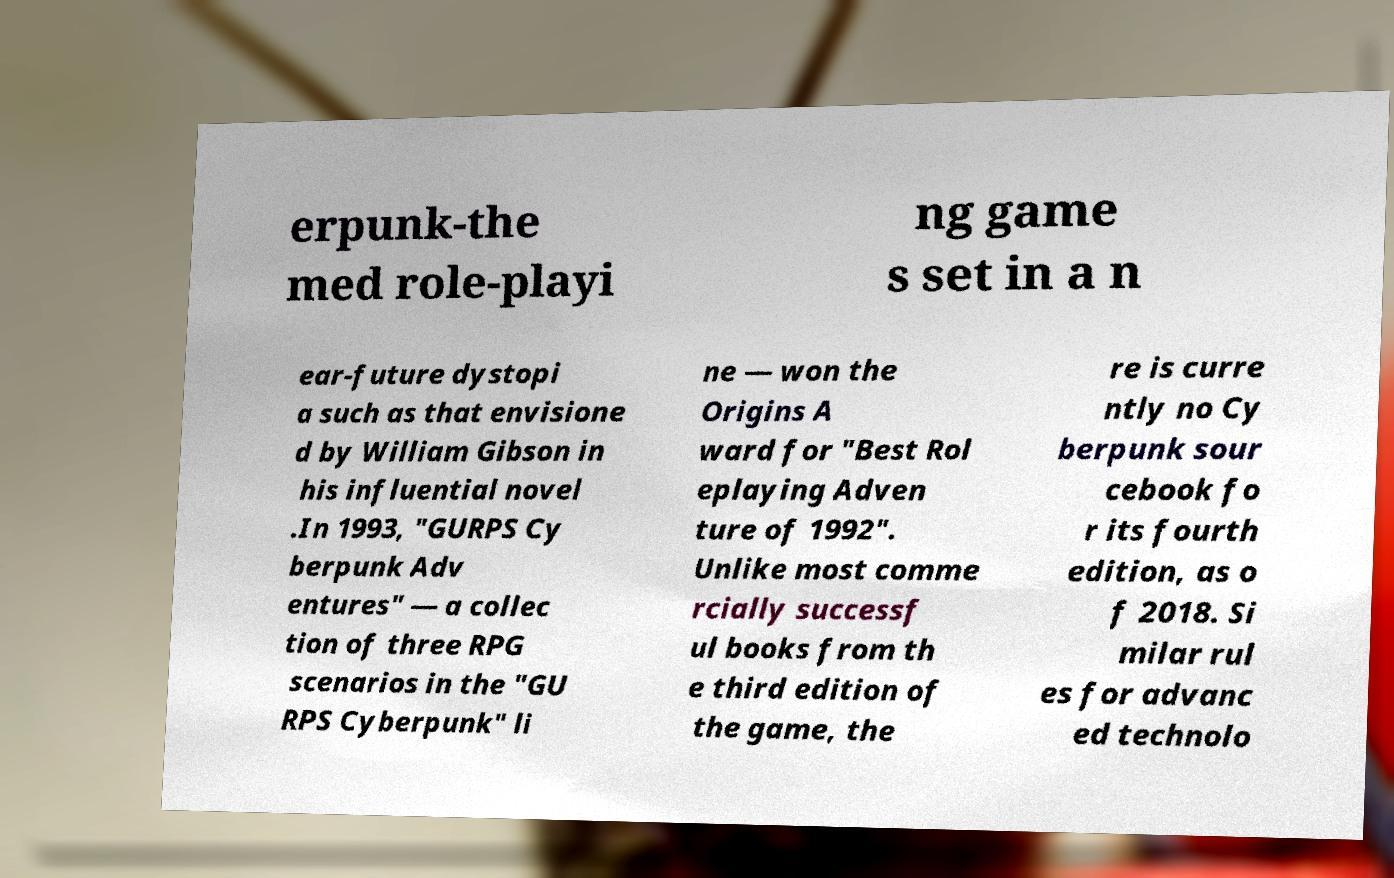There's text embedded in this image that I need extracted. Can you transcribe it verbatim? erpunk-the med role-playi ng game s set in a n ear-future dystopi a such as that envisione d by William Gibson in his influential novel .In 1993, "GURPS Cy berpunk Adv entures" — a collec tion of three RPG scenarios in the "GU RPS Cyberpunk" li ne — won the Origins A ward for "Best Rol eplaying Adven ture of 1992". Unlike most comme rcially successf ul books from th e third edition of the game, the re is curre ntly no Cy berpunk sour cebook fo r its fourth edition, as o f 2018. Si milar rul es for advanc ed technolo 